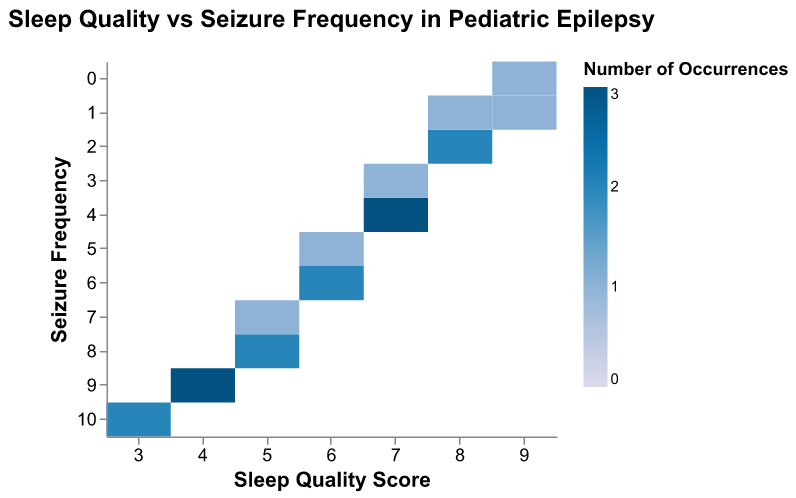What's the title of the figure? The title is usually located at the top of the figure and summarizes what the heatmap represents. In this case, it is "Sleep Quality vs Seizure Frequency in Pediatric Epilepsy."
Answer: Sleep Quality vs Seizure Frequency in Pediatric Epilepsy What does the color in the heatmap represent? The color represents the number of occurrences of each combination of Sleep Quality Score and Seizure Frequency. Lighter colors indicate fewer occurrences, and darker colors indicate more occurrences.
Answer: Number of Occurrences Which Sleep Quality Score and Seizure Frequency combination has the most occurrences? Look for the darkest color on the heatmap, which indicates the highest number of occurrences. The combination of Sleep Quality Score of 4 and Seizure Frequency of 9 has the most occurrences.
Answer: Sleep Quality Score of 4 and Seizure Frequency of 9 Is there a general trend between Sleep Quality Scores and Seizure Frequency? By observing the heatmap, one can see that higher Sleep Quality Scores are generally associated with lower seizure frequencies and vice versa.
Answer: Higher Sleep Quality Scores are generally associated with lower seizure frequencies What is the Seizure Frequency when the Sleep Quality Score is 9? Locate the column for Sleep Quality Score of 9 and identify the corresponding seizure frequency values. The values are 1 and 0.
Answer: 1 and 0 How many occurrences are there for a Sleep Quality Score of 7 and a Seizure Frequency of 4? Identify the intersection of Sleep Quality Score of 7 and Seizure Frequency of 4 on the heatmap and check the color intensity. It is medium, indicating that this combination occurs 3 times.
Answer: 3 Compare the number of occurrences for Sleep Quality Score 8 with Seizure Frequency 2 and Sleep Quality Score 5 with Seizure Frequency 8 Locate both combinations on the heatmap and compare their color intensities. The combination of Sleep Quality Score 8 and Seizure Frequency 2 occurs more frequently than Sleep Quality Score 5 with Seizure Frequency 8.
Answer: Sleep Quality Score 8 with Seizure Frequency 2 has more occurrences What's the range of Seizure Frequencies depicted in the heatmap? Look at the y-axis, which represents the Seizure Frequency, and note the highest and lowest values. The range of Seizure Frequencies is from 0 to 10.
Answer: 0 to 10 Are there any Sleep Quality Scores that do not appear at all in the data? Identify columns that have no color, indicating no occurrences. All scores from 3 to 9 appear, so there are no missing scores.
Answer: No, all scores appear 